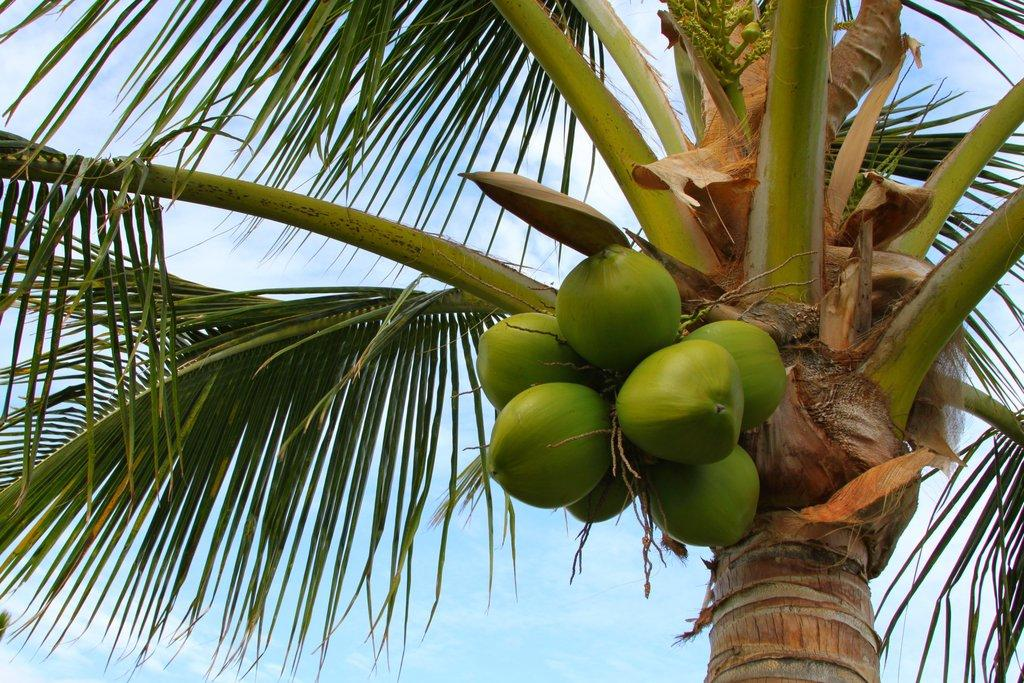What type of tree is in the image? There is a coconut tree in the image. Are there any coconuts on the tree? Yes, there are coconuts on the tree. What can be seen in the background of the image? The sky is visible in the background of the image. Is there a stream of water flowing near the coconut tree in the image? There is no stream of water visible in the image. What type of lumber is being used to support the coconut tree in the image? There is no lumber or support structure visible in the image; the coconut tree is standing on its own. 